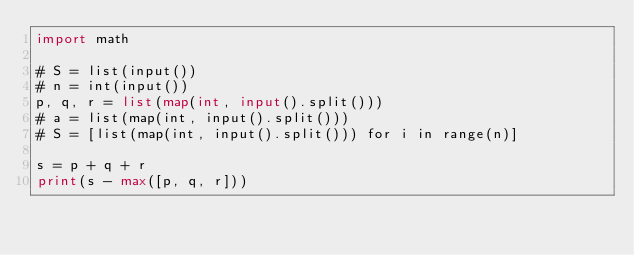Convert code to text. <code><loc_0><loc_0><loc_500><loc_500><_Python_>import math

# S = list(input())
# n = int(input())
p, q, r = list(map(int, input().split()))
# a = list(map(int, input().split()))
# S = [list(map(int, input().split())) for i in range(n)]

s = p + q + r
print(s - max([p, q, r]))</code> 